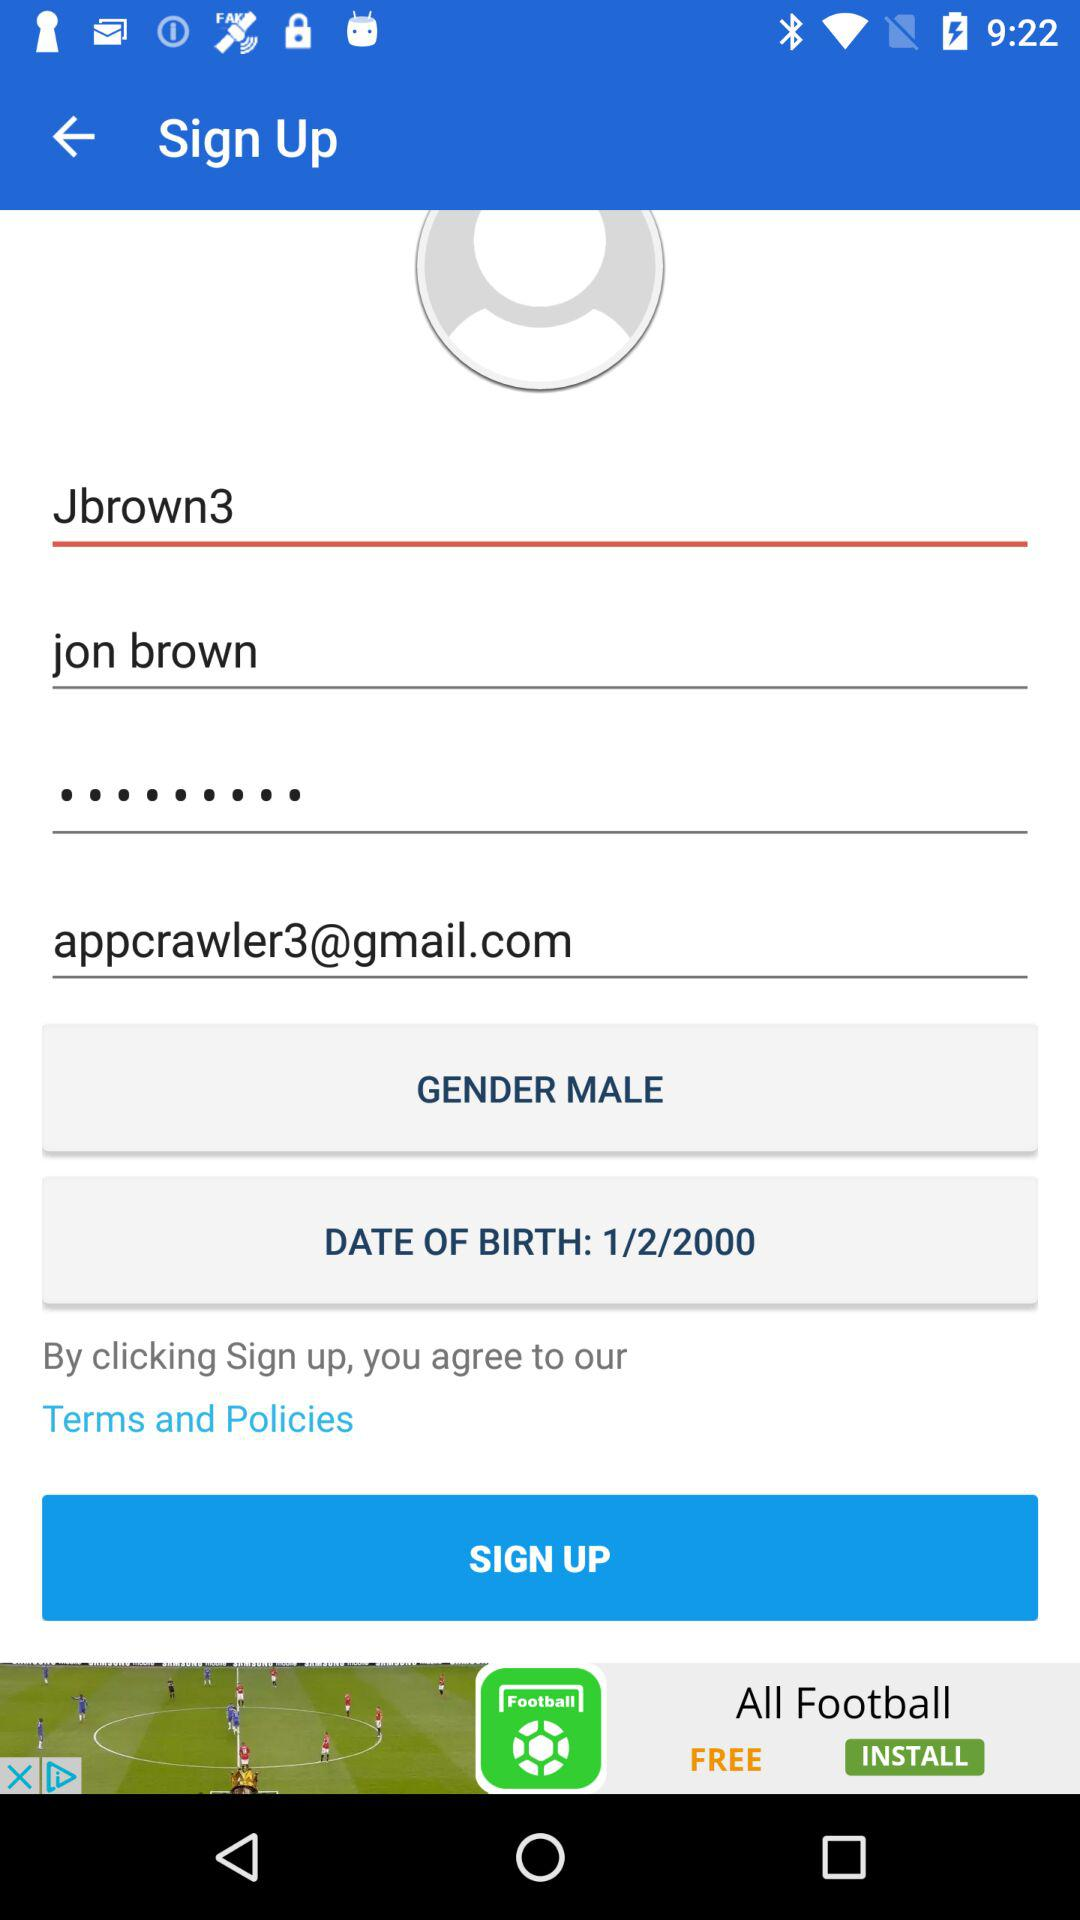What is the entered email address? The email address is appcrawler3@gmail.com. 